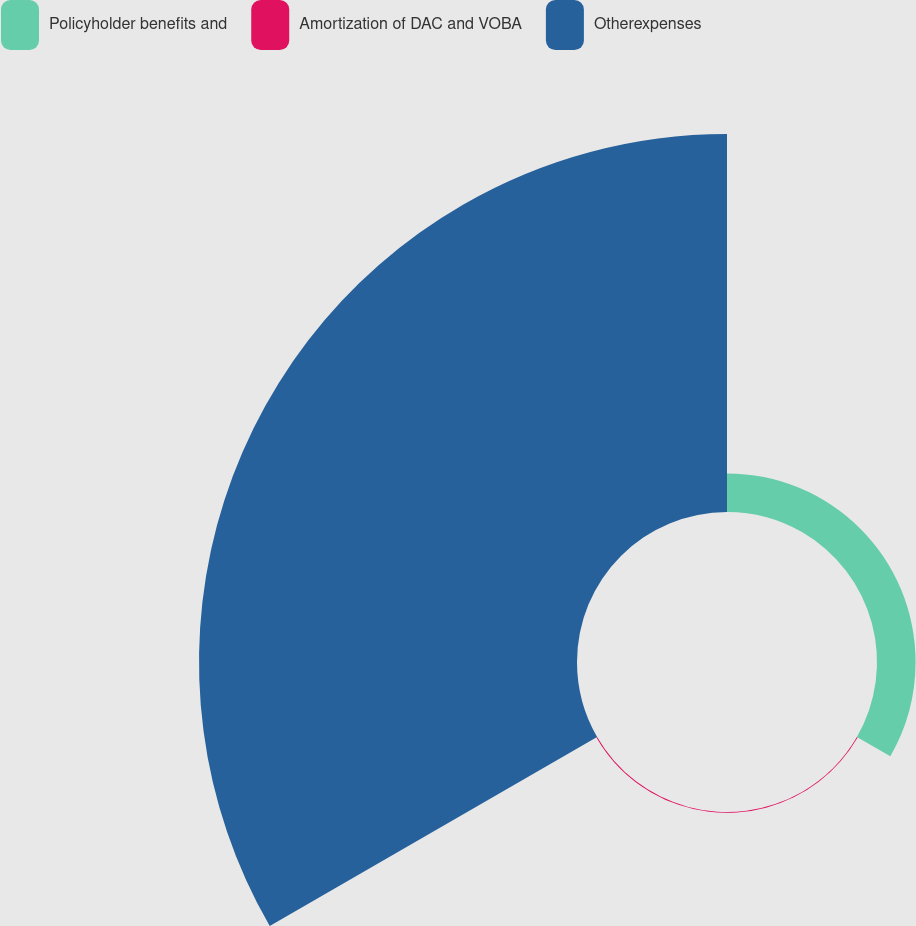<chart> <loc_0><loc_0><loc_500><loc_500><pie_chart><fcel>Policyholder benefits and<fcel>Amortization of DAC and VOBA<fcel>Otherexpenses<nl><fcel>9.24%<fcel>0.2%<fcel>90.56%<nl></chart> 